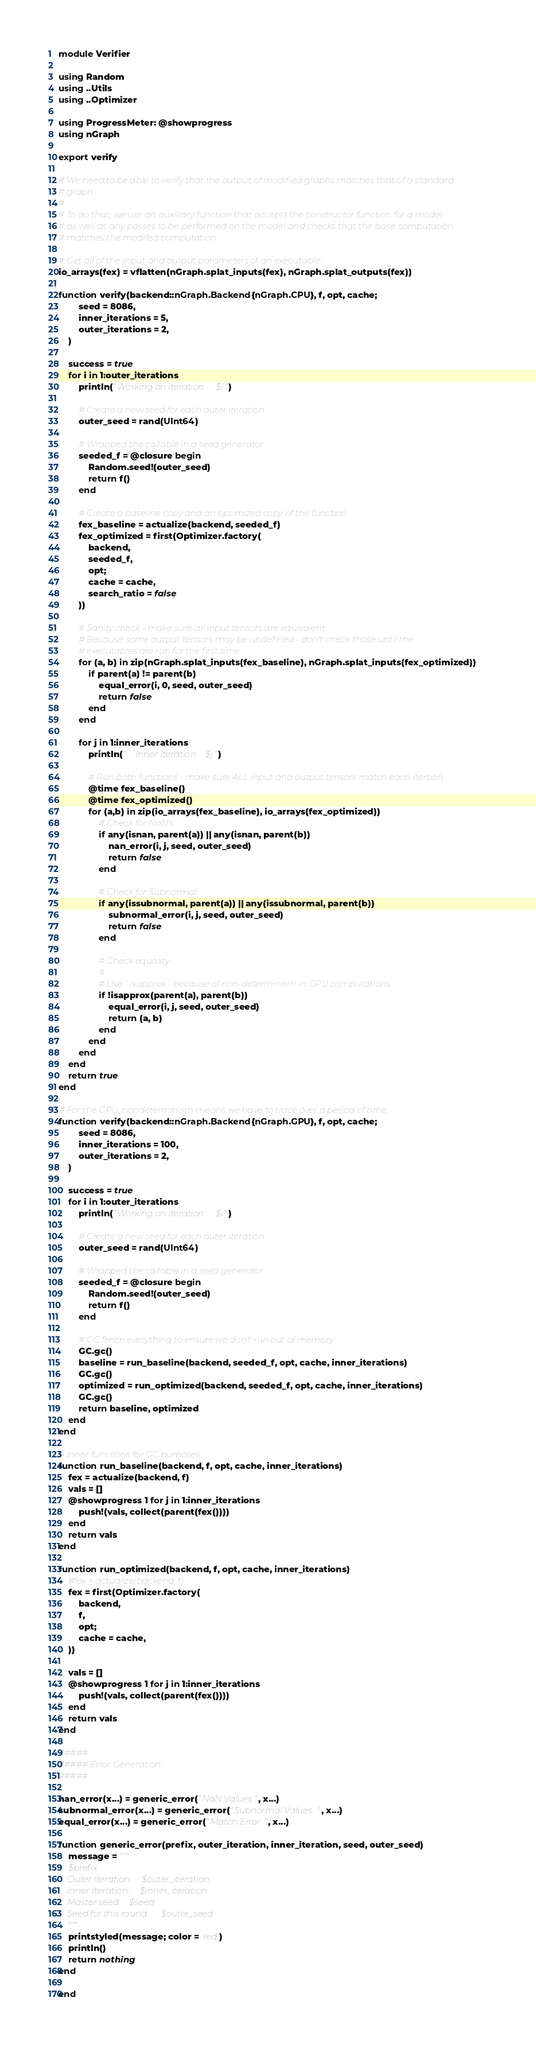Convert code to text. <code><loc_0><loc_0><loc_500><loc_500><_Julia_>module Verifier

using Random
using ..Utils
using ..Optimizer

using ProgressMeter: @showprogress
using nGraph

export verify

# We need to be able to verify that the output of modified graphs matches that of a standard
# graph.
#
# To do that, we use an auxiliary function that accepts the constructor function for a model
# as well as any passes to be performed on the model and checks that the base computation
# matches the modifed computation.

# Get all of the input and output parameters of an executable.
io_arrays(fex) = vflatten(nGraph.splat_inputs(fex), nGraph.splat_outputs(fex))

function verify(backend::nGraph.Backend{nGraph.CPU}, f, opt, cache;
        seed = 8086,
        inner_iterations = 5,
        outer_iterations = 2,
    )

    success = true
    for i in 1:outer_iterations
        println("Working on iteration $i")

        # Create a new seed for each outer iteration.
        outer_seed = rand(UInt64) 

        # Wrapped the callable in a seed generator
        seeded_f = @closure begin
            Random.seed!(outer_seed)
            return f()
        end

        # Create a baseline copy and an optimized copy of the function.
        fex_baseline = actualize(backend, seeded_f)
        fex_optimized = first(Optimizer.factory(
            backend, 
            seeded_f, 
            opt; 
            cache = cache, 
            search_ratio = false
        ))

        # Sanity check - make sure all input tensors are equivalent.
        # Because some output tensors may be undefined - don't check those until the
        # executables are run for the first time.
        for (a, b) in zip(nGraph.splat_inputs(fex_baseline), nGraph.splat_inputs(fex_optimized))
            if parent(a) != parent(b)
                equal_error(i, 0, seed, outer_seed)
                return false
            end
        end
        
        for j in 1:inner_iterations
            println("    Inner Iteration $j")

            # Run both functions - make sure ALL input and output tensors match each itertion.
            @time fex_baseline() 
            @time fex_optimized()
            for (a,b) in zip(io_arrays(fex_baseline), io_arrays(fex_optimized))
                # Check for NaN's
                if any(isnan, parent(a)) || any(isnan, parent(b))
                    nan_error(i, j, seed, outer_seed)
                    return false
                end

                # Check for Subnormal
                if any(issubnormal, parent(a)) || any(issubnormal, parent(b))
                    subnormal_error(i, j, seed, outer_seed)
                    return false
                end

                # Check equality
                #
                # Use `isapprox` because of non-determinism in GPU computations.
                if !isapprox(parent(a), parent(b))
                    equal_error(i, j, seed, outer_seed)
                    return (a, b)
                end
            end
        end
    end
    return true
end

# For the GPU, nondeterminism means we have to trace over a period of time.
function verify(backend::nGraph.Backend{nGraph.GPU}, f, opt, cache;
        seed = 8086,
        inner_iterations = 100,
        outer_iterations = 2,
    )

    success = true
    for i in 1:outer_iterations
        println("Working on iteration $i")

        # Create a new seed for each outer iteration.
        outer_seed = rand(UInt64) 

        # Wrapped the callable in a seed generator
        seeded_f = @closure begin
            Random.seed!(outer_seed)
            return f()
        end

        # GC fence everything to ensure we don't run out of memory.
        GC.gc()
        baseline = run_baseline(backend, seeded_f, opt, cache, inner_iterations)
        GC.gc()
        optimized = run_optimized(backend, seeded_f, opt, cache, inner_iterations)
        GC.gc()
        return baseline, optimized
    end
end

# Inner functions for GC purposes.
function run_baseline(backend, f, opt, cache, inner_iterations)
    fex = actualize(backend, f)
    vals = []
    @showprogress 1 for j in 1:inner_iterations
        push!(vals, collect(parent(fex())))
    end
    return vals
end

function run_optimized(backend, f, opt, cache, inner_iterations)
    #fex = actualize(backend, f)
    fex = first(Optimizer.factory(
        backend, 
        f, 
        opt; 
        cache = cache, 
    ))

    vals = []
    @showprogress 1 for j in 1:inner_iterations
        push!(vals, collect(parent(fex())))
    end
    return vals
end

#####
##### Error Generation.
#####

nan_error(x...) = generic_error("NaN Values", x...)
subnormal_error(x...) = generic_error("Subnormal Values", x...)
equal_error(x...) = generic_error("Match Error", x...)

function generic_error(prefix, outer_iteration, inner_iteration, seed, outer_seed)
    message = """
    $prefix
    Outer Iteration: $outer_iteration
    Inner Iteration: $inner_iteration
    Master seed: $seed
    Seed for this round: $outer_seed
    """
    printstyled(message; color = :red)
    println()
    return nothing
end

end
</code> 